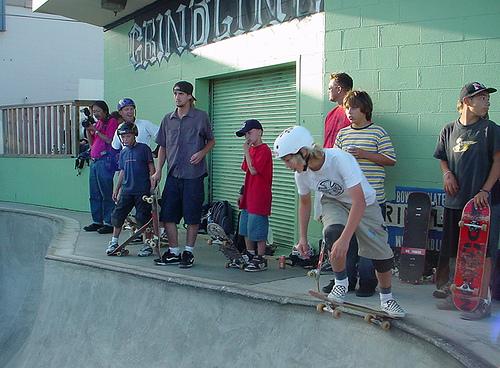How many people wearing helmet?
Keep it brief. 3. Where does the small boy in red shirt have his hand?
Answer briefly. Mouth. What sport is this?
Short answer required. Skateboarding. What color is the building behind the people?
Quick response, please. Green. Is the seated boy in the white shirt breaking an airport safety rule?
Keep it brief. No. 